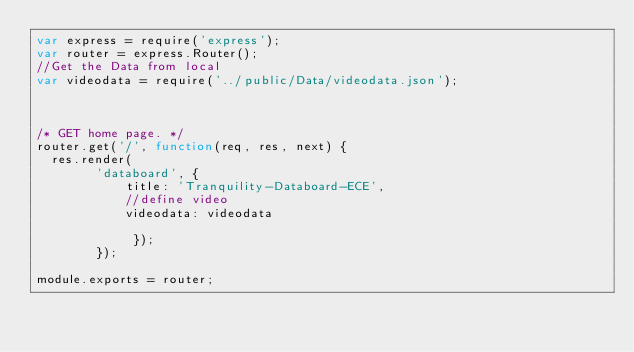<code> <loc_0><loc_0><loc_500><loc_500><_JavaScript_>var express = require('express');
var router = express.Router();
//Get the Data from local 
var videodata = require('../public/Data/videodata.json');



/* GET home page. */
router.get('/', function(req, res, next) {
  res.render(
		'databoard', { 
			title: 'Tranquility-Databoard-ECE',
			//define video 
			videodata: videodata

			 });
		});

module.exports = router;
</code> 